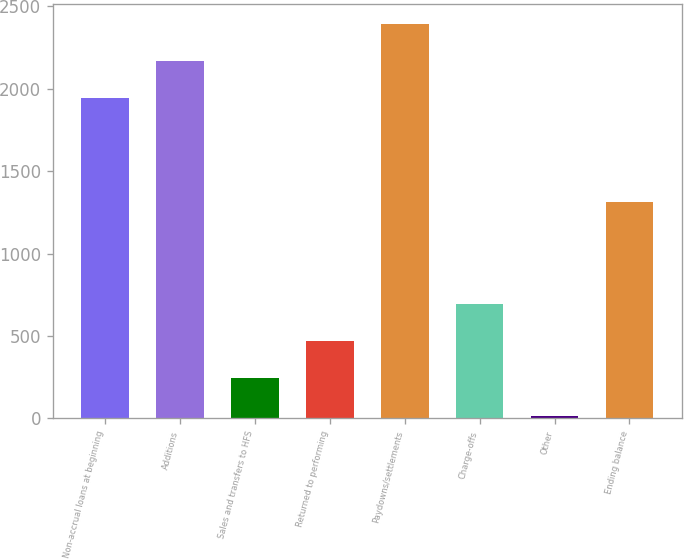<chart> <loc_0><loc_0><loc_500><loc_500><bar_chart><fcel>Non-accrual loans at beginning<fcel>Additions<fcel>Sales and transfers to HFS<fcel>Returned to performing<fcel>Paydowns/settlements<fcel>Charge-offs<fcel>Other<fcel>Ending balance<nl><fcel>1942<fcel>2168.7<fcel>241.7<fcel>468.4<fcel>2395.4<fcel>695.1<fcel>15<fcel>1311<nl></chart> 